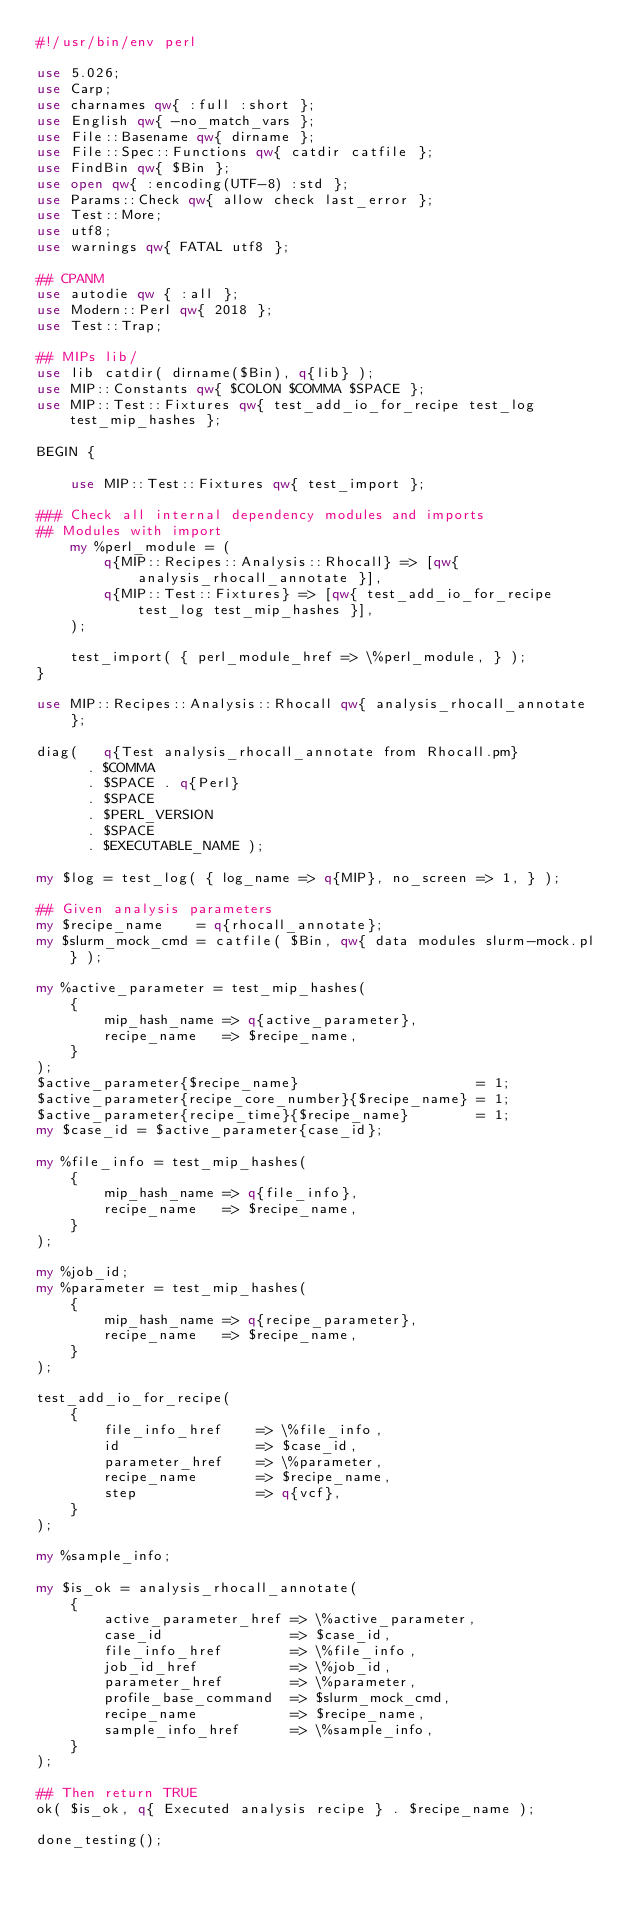Convert code to text. <code><loc_0><loc_0><loc_500><loc_500><_Perl_>#!/usr/bin/env perl

use 5.026;
use Carp;
use charnames qw{ :full :short };
use English qw{ -no_match_vars };
use File::Basename qw{ dirname };
use File::Spec::Functions qw{ catdir catfile };
use FindBin qw{ $Bin };
use open qw{ :encoding(UTF-8) :std };
use Params::Check qw{ allow check last_error };
use Test::More;
use utf8;
use warnings qw{ FATAL utf8 };

## CPANM
use autodie qw { :all };
use Modern::Perl qw{ 2018 };
use Test::Trap;

## MIPs lib/
use lib catdir( dirname($Bin), q{lib} );
use MIP::Constants qw{ $COLON $COMMA $SPACE };
use MIP::Test::Fixtures qw{ test_add_io_for_recipe test_log test_mip_hashes };

BEGIN {

    use MIP::Test::Fixtures qw{ test_import };

### Check all internal dependency modules and imports
## Modules with import
    my %perl_module = (
        q{MIP::Recipes::Analysis::Rhocall} => [qw{ analysis_rhocall_annotate }],
        q{MIP::Test::Fixtures} => [qw{ test_add_io_for_recipe test_log test_mip_hashes }],
    );

    test_import( { perl_module_href => \%perl_module, } );
}

use MIP::Recipes::Analysis::Rhocall qw{ analysis_rhocall_annotate };

diag(   q{Test analysis_rhocall_annotate from Rhocall.pm}
      . $COMMA
      . $SPACE . q{Perl}
      . $SPACE
      . $PERL_VERSION
      . $SPACE
      . $EXECUTABLE_NAME );

my $log = test_log( { log_name => q{MIP}, no_screen => 1, } );

## Given analysis parameters
my $recipe_name    = q{rhocall_annotate};
my $slurm_mock_cmd = catfile( $Bin, qw{ data modules slurm-mock.pl } );

my %active_parameter = test_mip_hashes(
    {
        mip_hash_name => q{active_parameter},
        recipe_name   => $recipe_name,
    }
);
$active_parameter{$recipe_name}                     = 1;
$active_parameter{recipe_core_number}{$recipe_name} = 1;
$active_parameter{recipe_time}{$recipe_name}        = 1;
my $case_id = $active_parameter{case_id};

my %file_info = test_mip_hashes(
    {
        mip_hash_name => q{file_info},
        recipe_name   => $recipe_name,
    }
);

my %job_id;
my %parameter = test_mip_hashes(
    {
        mip_hash_name => q{recipe_parameter},
        recipe_name   => $recipe_name,
    }
);

test_add_io_for_recipe(
    {
        file_info_href    => \%file_info,
        id                => $case_id,
        parameter_href    => \%parameter,
        recipe_name       => $recipe_name,
        step              => q{vcf},
    }
);

my %sample_info;

my $is_ok = analysis_rhocall_annotate(
    {
        active_parameter_href => \%active_parameter,
        case_id               => $case_id,
        file_info_href        => \%file_info,
        job_id_href           => \%job_id,
        parameter_href        => \%parameter,
        profile_base_command  => $slurm_mock_cmd,
        recipe_name           => $recipe_name,
        sample_info_href      => \%sample_info,
    }
);

## Then return TRUE
ok( $is_ok, q{ Executed analysis recipe } . $recipe_name );

done_testing();
</code> 